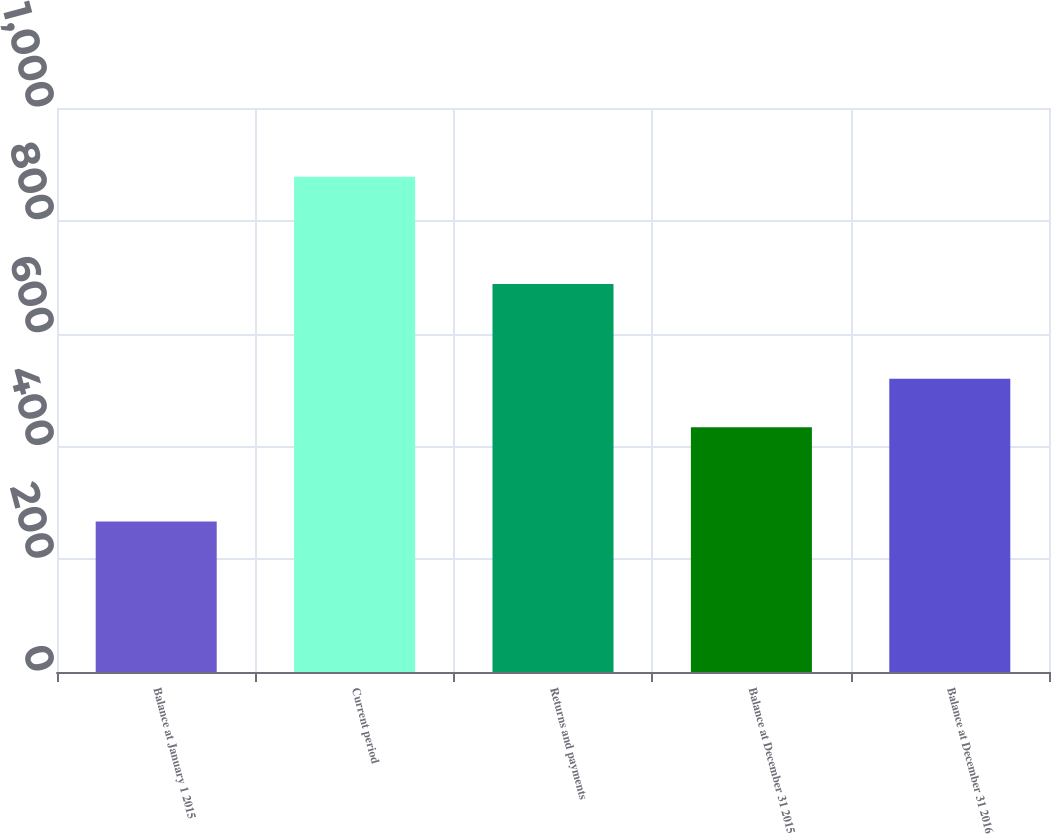Convert chart to OTSL. <chart><loc_0><loc_0><loc_500><loc_500><bar_chart><fcel>Balance at January 1 2015<fcel>Current period<fcel>Returns and payments<fcel>Balance at December 31 2015<fcel>Balance at December 31 2016<nl><fcel>267<fcel>878<fcel>688<fcel>434<fcel>520<nl></chart> 